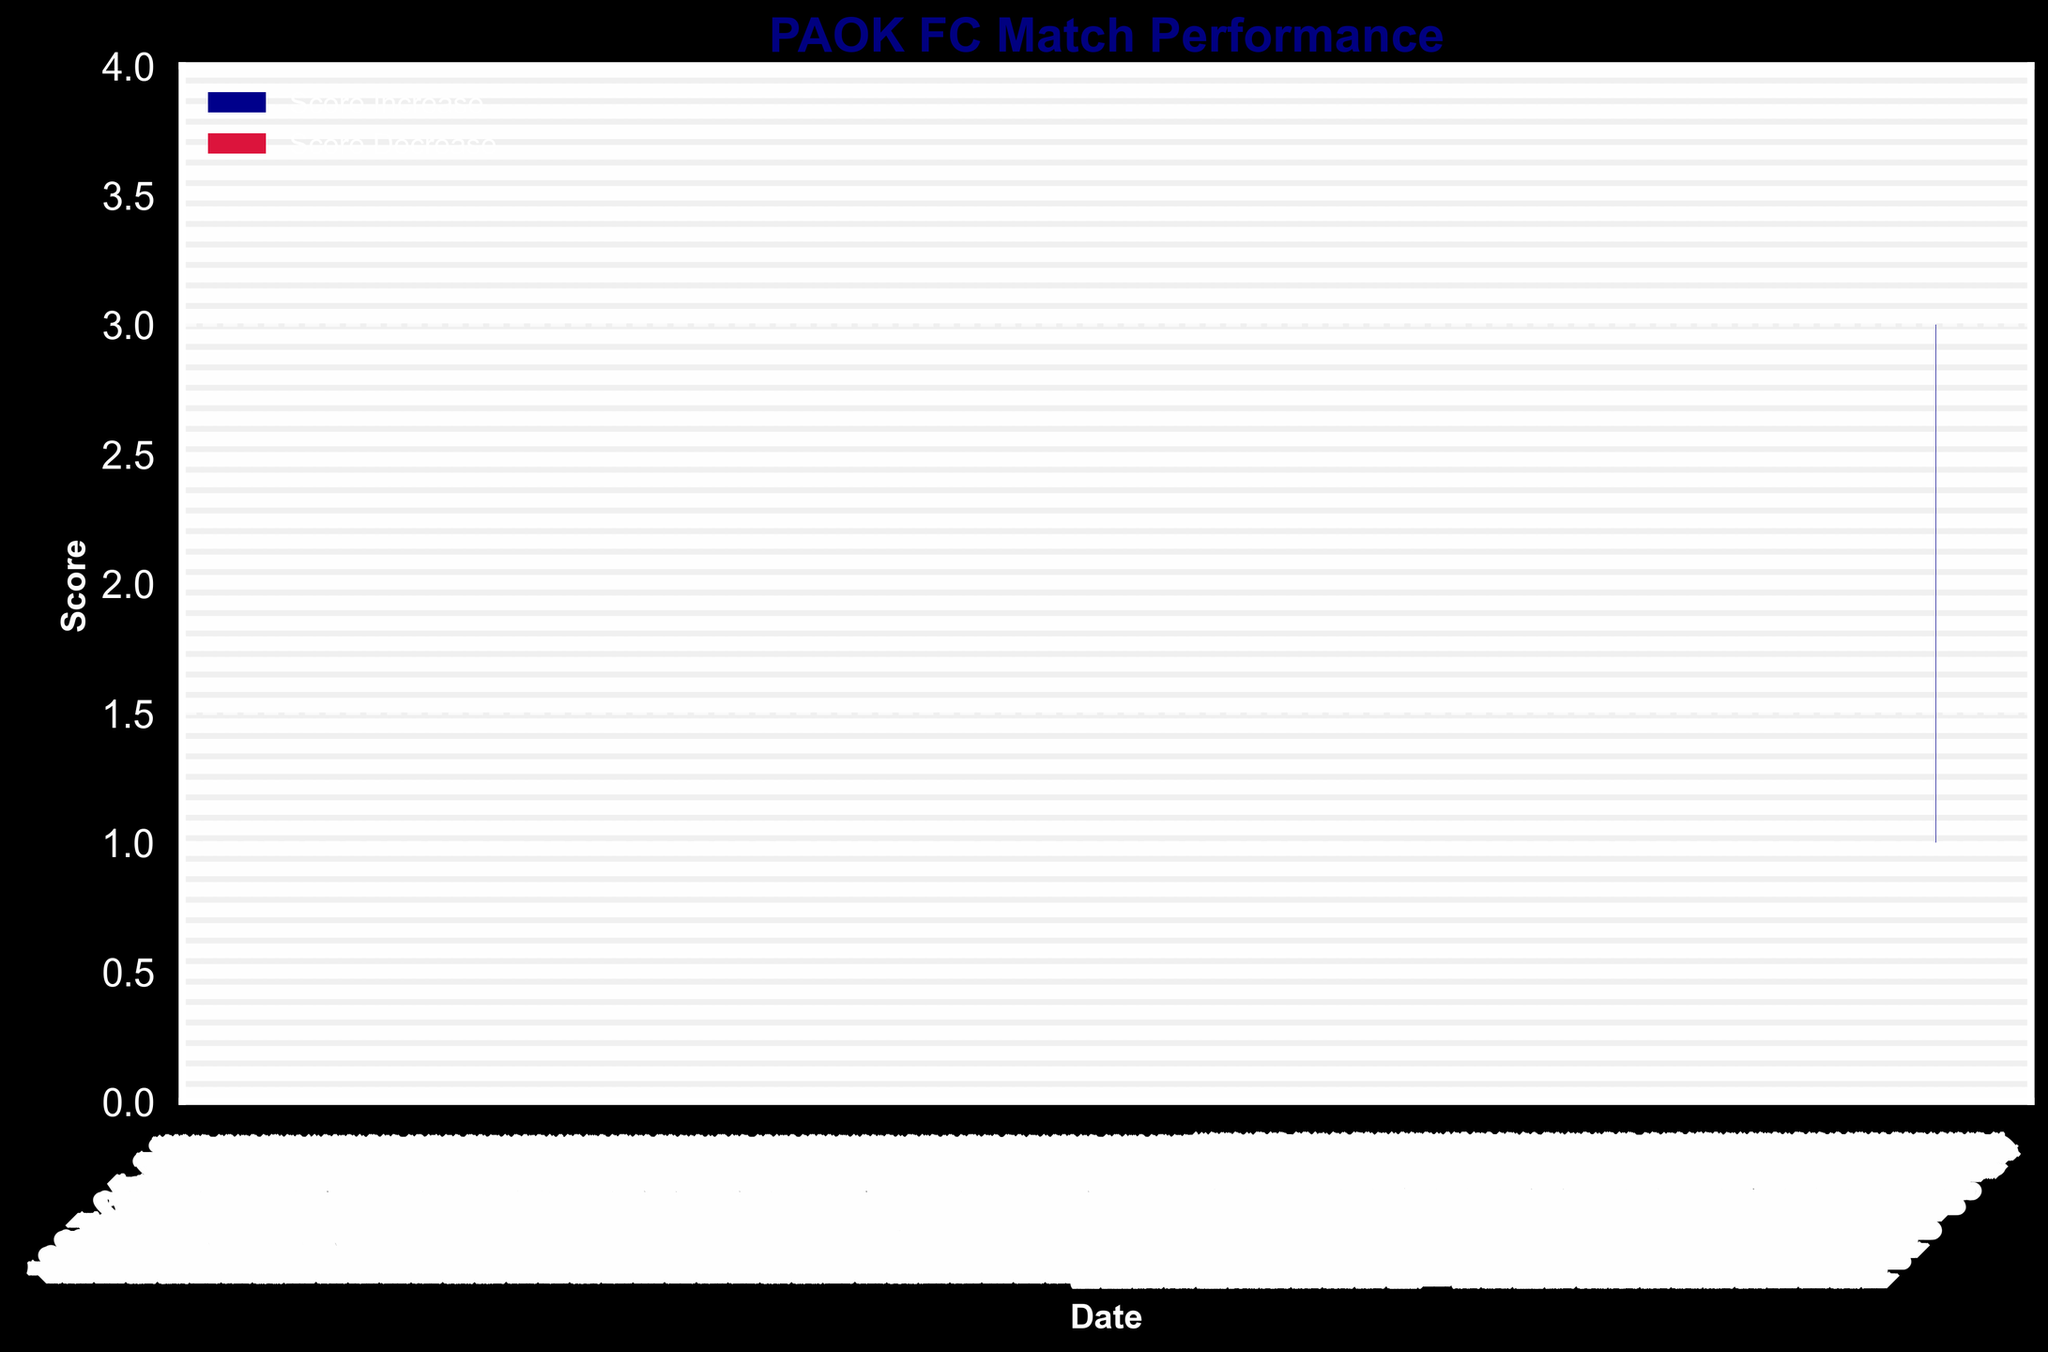What is the title of the chart? The title of the chart is located at the top center and provides a summary of what the chart represents. Here, it is "PAOK FC Match Performance"
Answer: PAOK FC Match Performance What do the colors on the chart represent? The two colors on the bars represent a score increase and a score decrease. The dark blue color represents a score increase, while crimson represents a score decrease.
Answer: Dark blue: Score Increase, Crimson: Score Decrease On which date did PAOK FC achieve the highest closing score? To find this, look for the highest bar indicating the closing score. The date corresponding to the highest closing score is October 30th, 2022, with a score of 4.
Answer: October 30, 2022 How many matches resulted in a score increase for PAOK FC? Count the number of dark blue bars, which represent score increases. There are 10 matches with score increases.
Answer: 10 Which month had the lowest number of score increases? Examine each month, count the number of dark blue bars, and compare. November 2022 had the lowest number of score increases with only one match that ended with an increased score (November 27, 2022).
Answer: November 2022 What was the average closing score in October 2022? Identify all the closing scores in October (2, 1, 2, 3, 4). Sum these scores to get 12, then divide by the number of matches (5) to find the average: 12 / 5 = 2.4.
Answer: 2.4 How many matches in September 2022 ended with a closing score lower than the opening score? Identify and count the crimson bars for September. Only one match in September 2022 ended with a closing score lower than the opening score (September 11, 2022).
Answer: 1 What was the range of high scores in December 2022? Find the high scores for December (2, 2, 3, 4). The range is the difference between the highest and lowest values: 4 - 2 = 2.
Answer: 2 Which match had the largest difference between the high and low scores? Examining the OHLC bars, the match on October 16th, 2022 had a high score of 3 and a low score of 1, giving a difference of 2 points.
Answer: October 16, 2022 Which dates had matches where the closing score was equal to the high score? For these dates, the closing and high score bars would be at the same height. These dates are August 20, 2022, September 25, 2022, October 30, 2022, December 18, 2022, and January 8, 2023.
Answer: August 20, 2022, September 25, 2022, October 30, 2022, December 18, 2022, January 8, 2023 